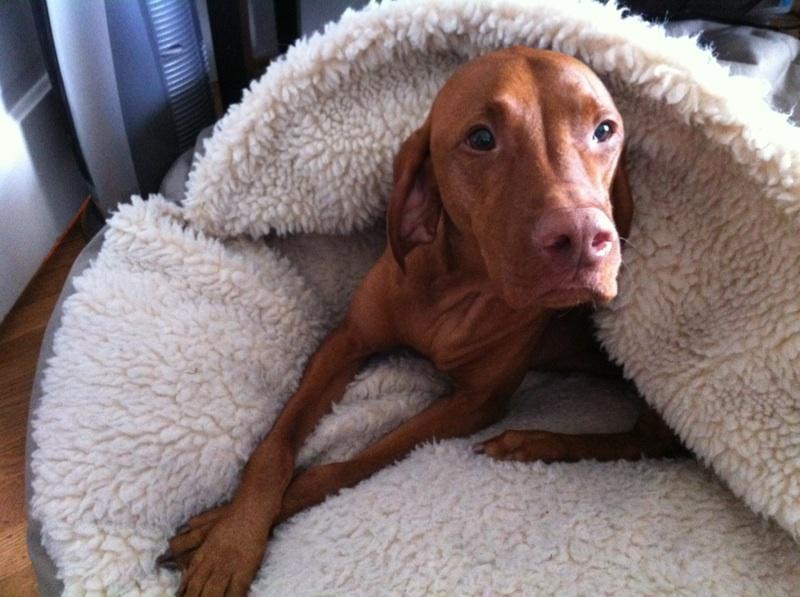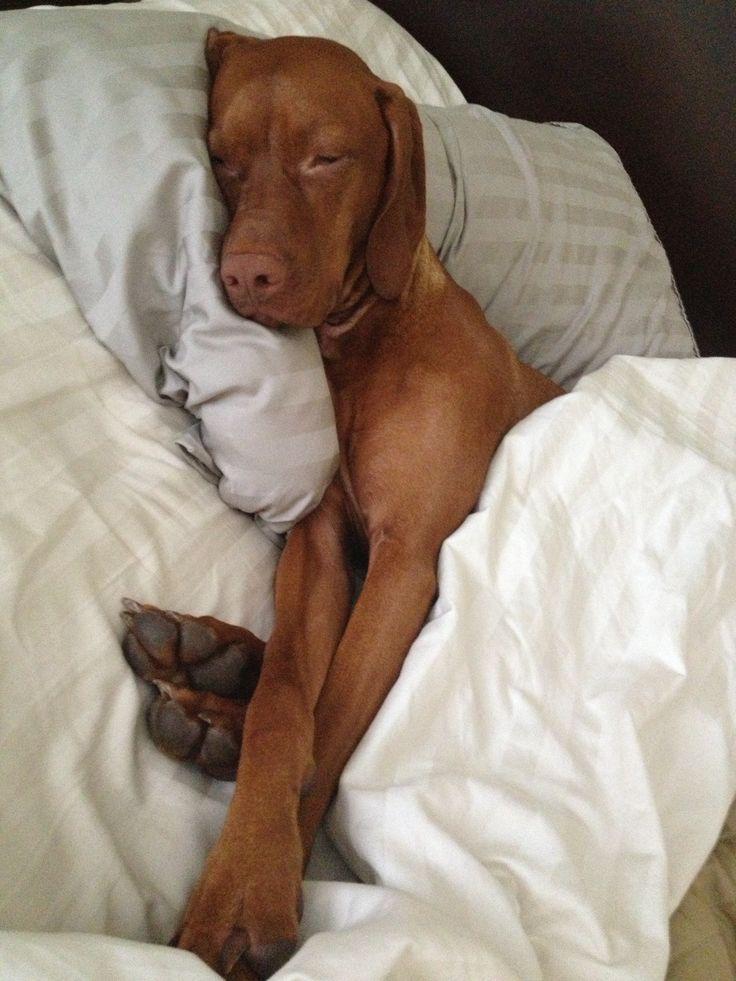The first image is the image on the left, the second image is the image on the right. Given the left and right images, does the statement "The right image shows a red-orange dog reclining in a bed with the side of its head on a pillow." hold true? Answer yes or no. Yes. The first image is the image on the left, the second image is the image on the right. Examine the images to the left and right. Is the description "There are only two dogs in total." accurate? Answer yes or no. Yes. 